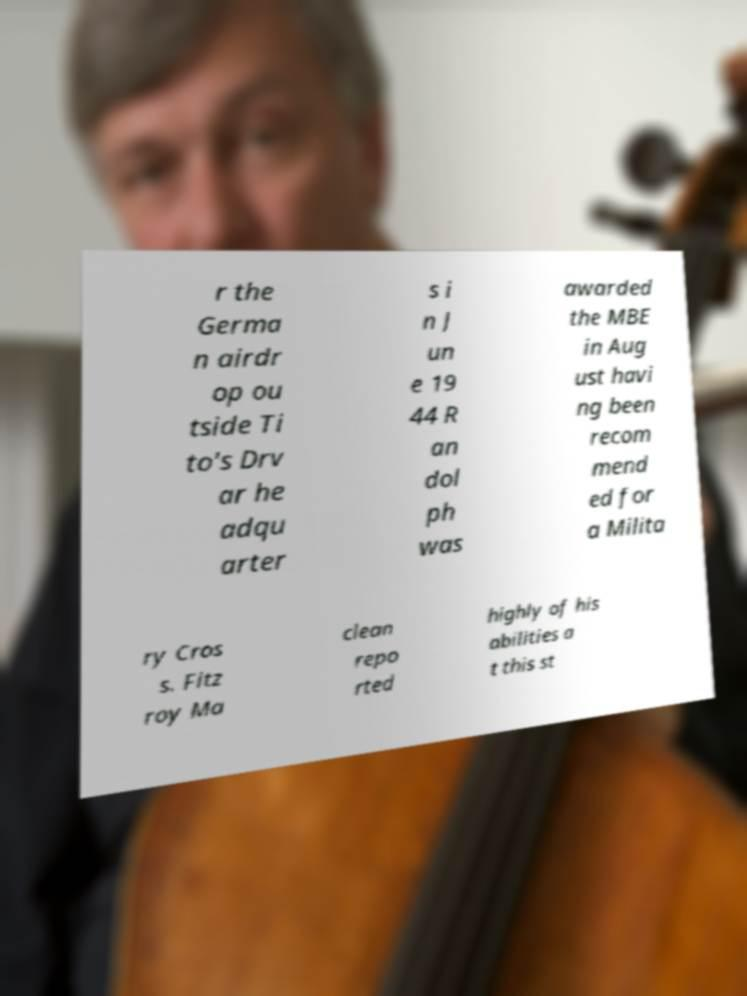I need the written content from this picture converted into text. Can you do that? r the Germa n airdr op ou tside Ti to's Drv ar he adqu arter s i n J un e 19 44 R an dol ph was awarded the MBE in Aug ust havi ng been recom mend ed for a Milita ry Cros s. Fitz roy Ma clean repo rted highly of his abilities a t this st 